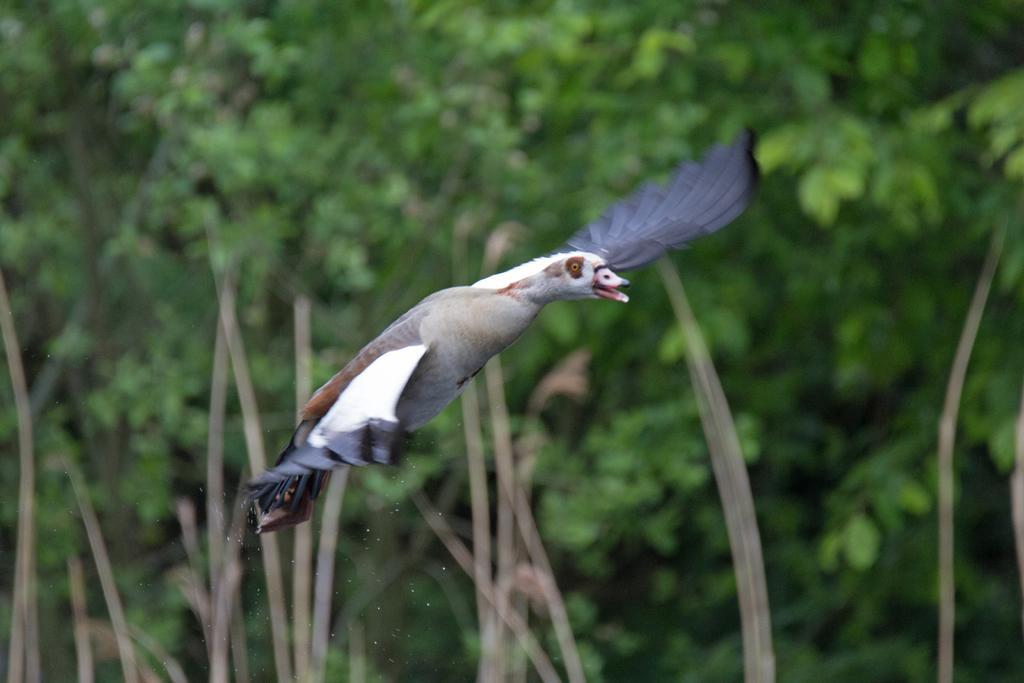In one or two sentences, can you explain what this image depicts? In the image there is a bird flying in the air and the background of the bird is blue. 